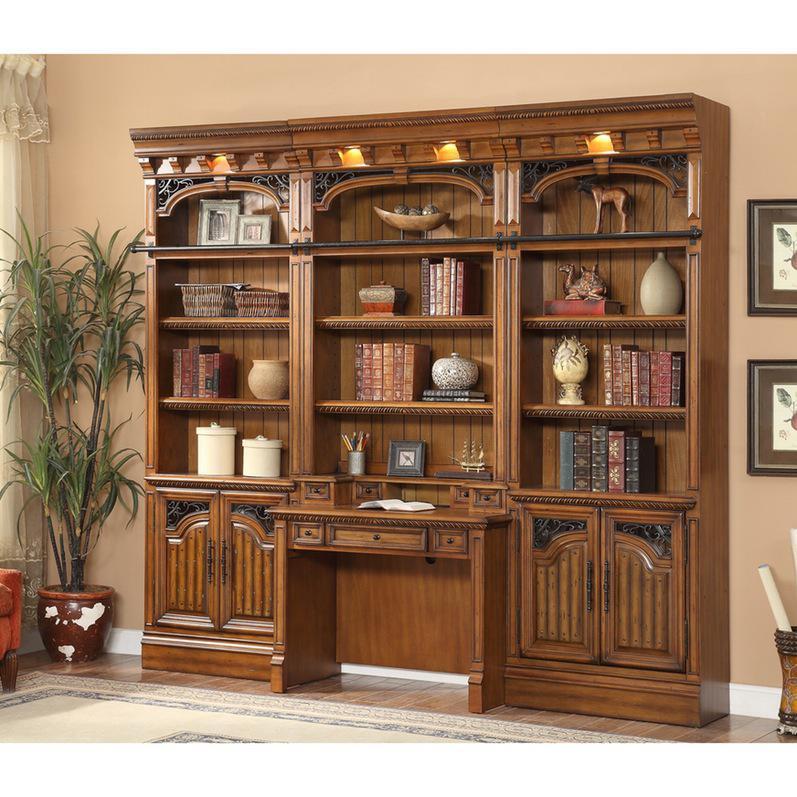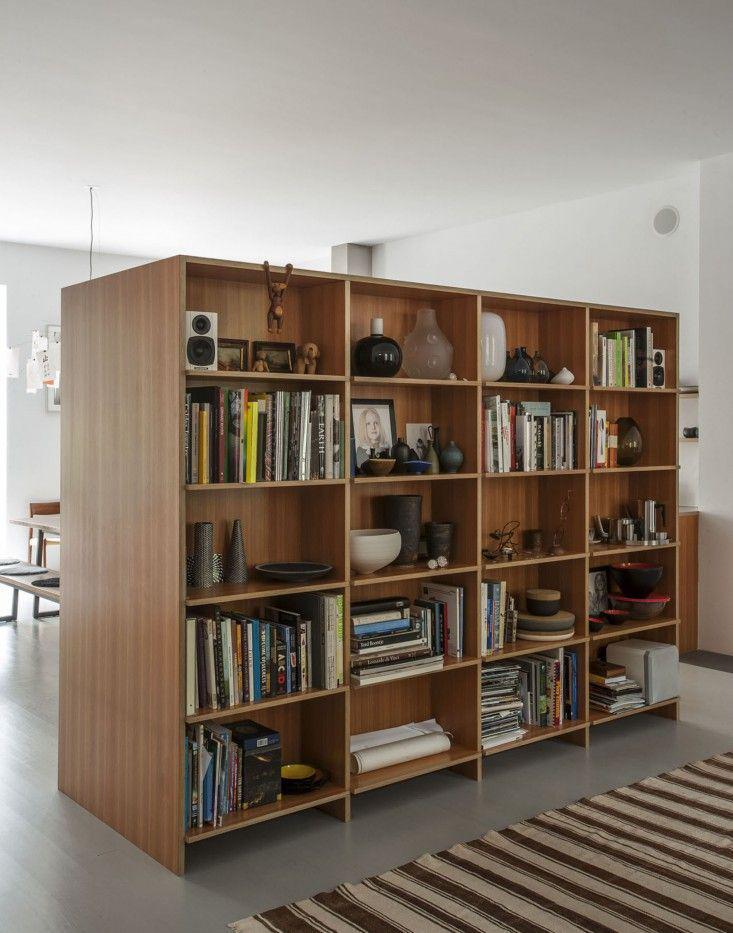The first image is the image on the left, the second image is the image on the right. Considering the images on both sides, is "In one of the images, a doorway with a view into another room is to the right of a tall white bookcase full of books that are mostly arranged vertically." valid? Answer yes or no. No. The first image is the image on the left, the second image is the image on the right. Assess this claim about the two images: "In at least one image there is a white bookshelf that is part of a kitchen that include silver appliances.". Correct or not? Answer yes or no. No. 